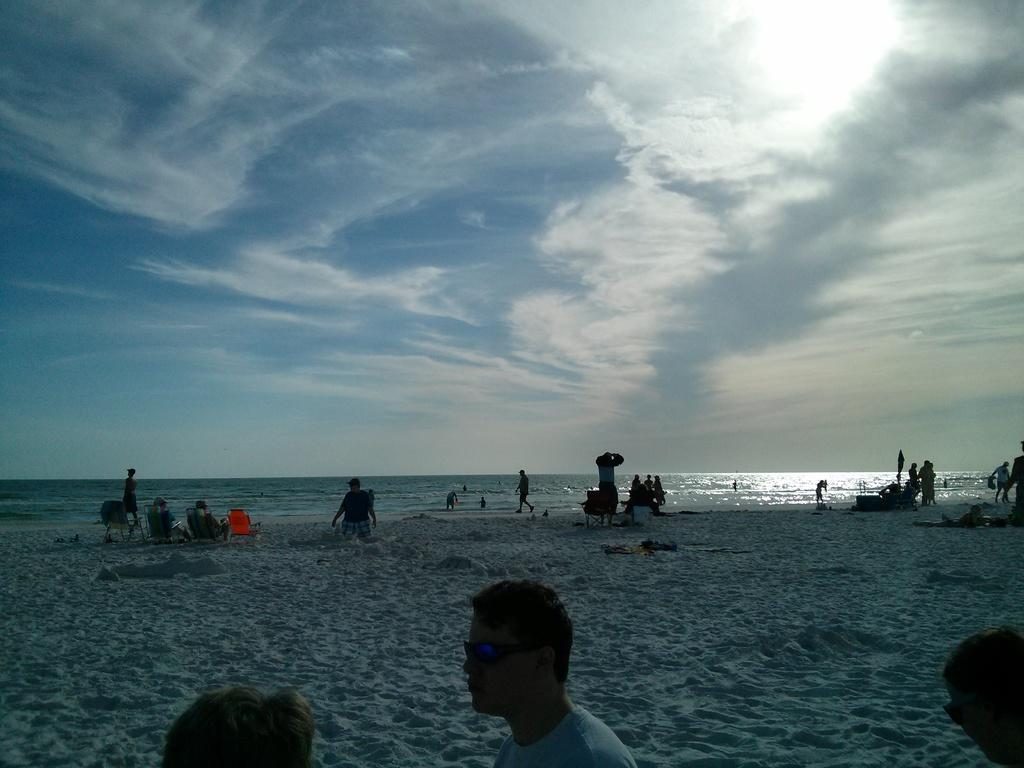How many people are at the bottom of the image? There are three persons at the bottom of the image. Can you describe the background of the image? The background includes a sand surface and an ocean. Are there any other people visible in the image besides the three at the bottom? Yes, there are persons in the background of the image. What can be seen in the sky in the image? There are clouds in the sky. What type of zinc is being offered to the persons in the image? There is no zinc present in the image, and no offer is being made. What topic are the persons discussing in the image? The image does not show any discussion or conversation among the persons. 